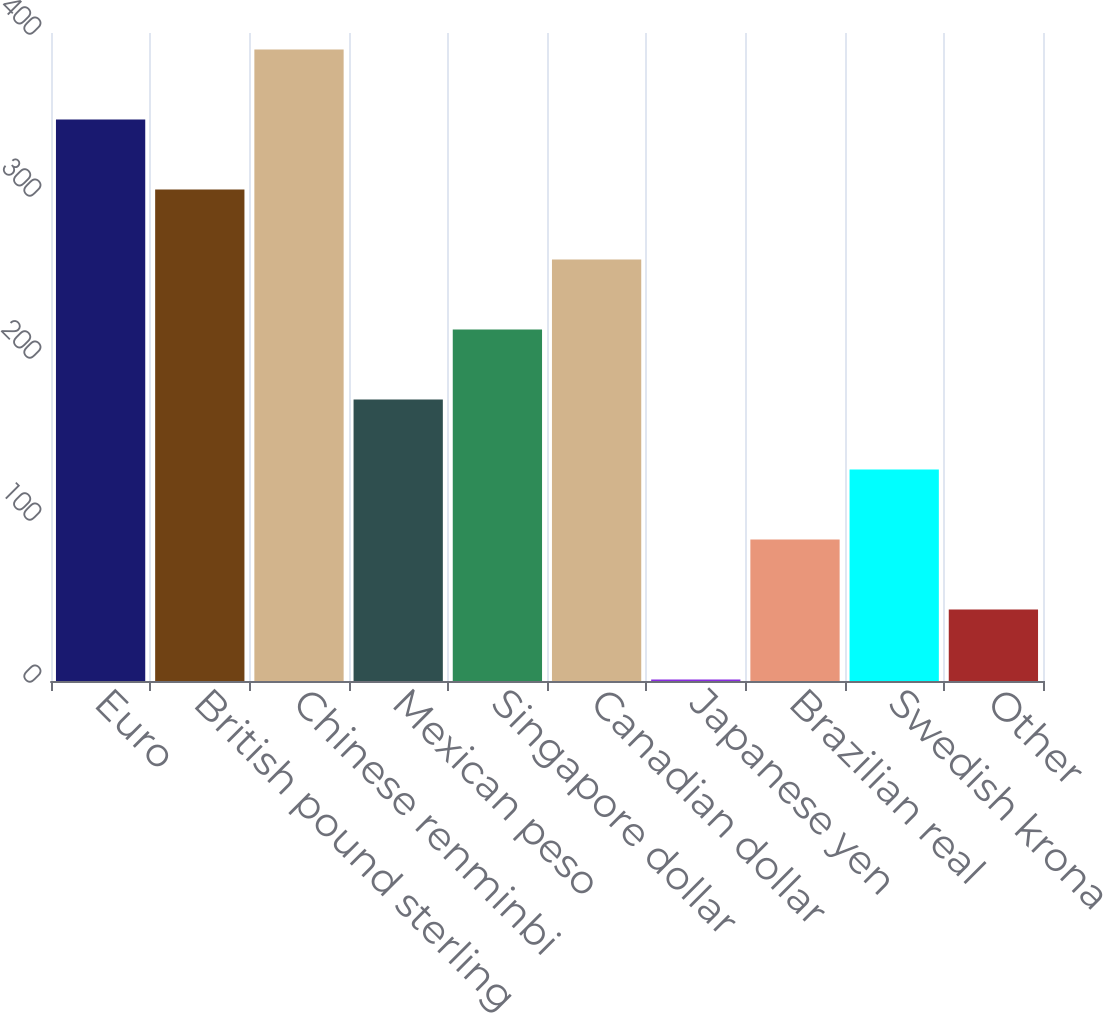<chart> <loc_0><loc_0><loc_500><loc_500><bar_chart><fcel>Euro<fcel>British pound sterling<fcel>Chinese renminbi<fcel>Mexican peso<fcel>Singapore dollar<fcel>Canadian dollar<fcel>Japanese yen<fcel>Brazilian real<fcel>Swedish krona<fcel>Other<nl><fcel>346.6<fcel>303.4<fcel>389.8<fcel>173.8<fcel>217<fcel>260.2<fcel>1<fcel>87.4<fcel>130.6<fcel>44.2<nl></chart> 